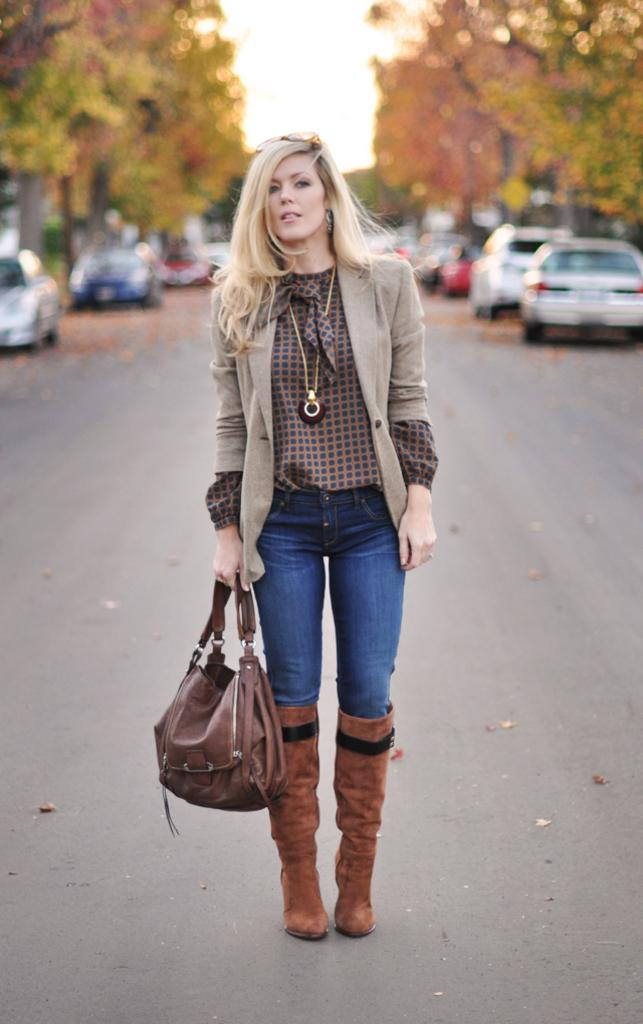Who is present in the image? There is a woman in the image. What is the woman doing in the image? The woman is standing in the image. What is the woman holding in the image? The woman is holding a handbag in the image. What can be seen in the distance in the image? There are vehicles and trees in the distance in the image. What type of clothing is the woman wearing in the image? The woman is wearing a jacket in the image. What type of guitar is the woman playing in the image? There is no guitar present in the image; the woman is holding a handbag. 